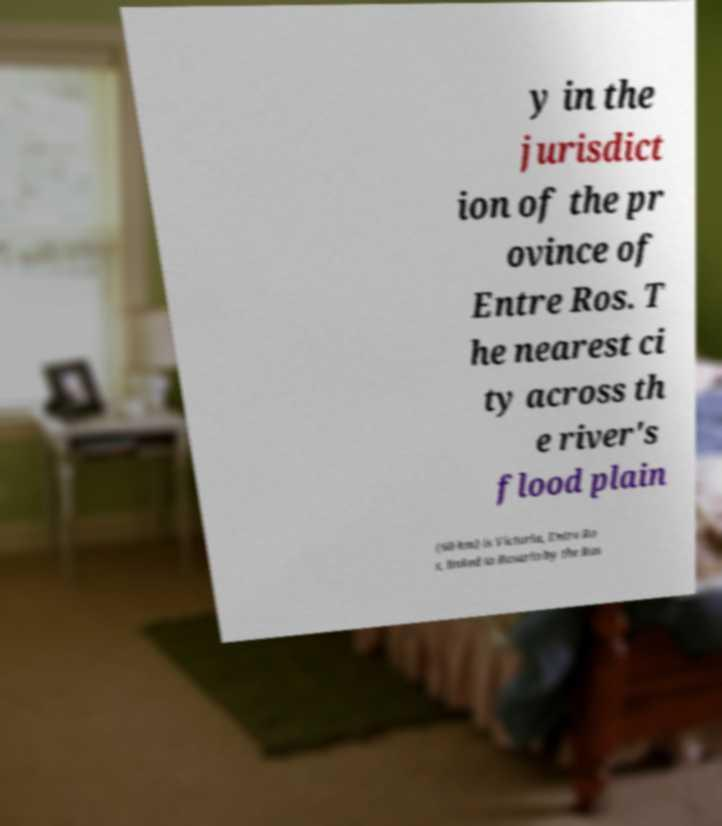I need the written content from this picture converted into text. Can you do that? y in the jurisdict ion of the pr ovince of Entre Ros. T he nearest ci ty across th e river's flood plain (60 km) is Victoria, Entre Ro s, linked to Rosario by the Ros 